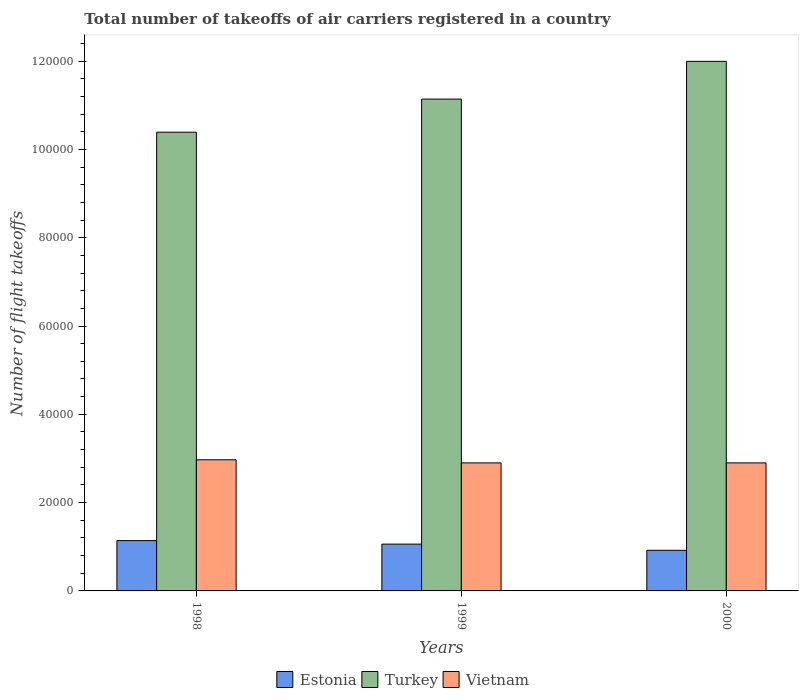How many different coloured bars are there?
Give a very brief answer. 3. Are the number of bars on each tick of the X-axis equal?
Give a very brief answer. Yes. How many bars are there on the 1st tick from the left?
Your answer should be compact. 3. In how many cases, is the number of bars for a given year not equal to the number of legend labels?
Provide a short and direct response. 0. What is the total number of flight takeoffs in Vietnam in 2000?
Your answer should be compact. 2.90e+04. Across all years, what is the maximum total number of flight takeoffs in Vietnam?
Your answer should be compact. 2.97e+04. Across all years, what is the minimum total number of flight takeoffs in Estonia?
Your answer should be compact. 9199. In which year was the total number of flight takeoffs in Turkey maximum?
Your answer should be very brief. 2000. What is the total total number of flight takeoffs in Vietnam in the graph?
Provide a succinct answer. 8.77e+04. What is the difference between the total number of flight takeoffs in Estonia in 1998 and that in 1999?
Offer a very short reply. 800. What is the difference between the total number of flight takeoffs in Vietnam in 2000 and the total number of flight takeoffs in Estonia in 1998?
Offer a terse response. 1.76e+04. What is the average total number of flight takeoffs in Estonia per year?
Make the answer very short. 1.04e+04. In the year 1998, what is the difference between the total number of flight takeoffs in Estonia and total number of flight takeoffs in Vietnam?
Offer a terse response. -1.83e+04. In how many years, is the total number of flight takeoffs in Vietnam greater than 4000?
Offer a very short reply. 3. What is the ratio of the total number of flight takeoffs in Estonia in 1999 to that in 2000?
Give a very brief answer. 1.15. Is the total number of flight takeoffs in Vietnam in 1998 less than that in 1999?
Offer a terse response. No. What is the difference between the highest and the second highest total number of flight takeoffs in Estonia?
Offer a very short reply. 800. What is the difference between the highest and the lowest total number of flight takeoffs in Vietnam?
Ensure brevity in your answer.  701. Is the sum of the total number of flight takeoffs in Vietnam in 1998 and 2000 greater than the maximum total number of flight takeoffs in Turkey across all years?
Keep it short and to the point. No. What does the 2nd bar from the right in 1999 represents?
Your response must be concise. Turkey. How many bars are there?
Make the answer very short. 9. Are all the bars in the graph horizontal?
Provide a short and direct response. No. Does the graph contain grids?
Make the answer very short. No. Where does the legend appear in the graph?
Your answer should be compact. Bottom center. How many legend labels are there?
Your response must be concise. 3. How are the legend labels stacked?
Keep it short and to the point. Horizontal. What is the title of the graph?
Keep it short and to the point. Total number of takeoffs of air carriers registered in a country. What is the label or title of the X-axis?
Keep it short and to the point. Years. What is the label or title of the Y-axis?
Offer a very short reply. Number of flight takeoffs. What is the Number of flight takeoffs of Estonia in 1998?
Your response must be concise. 1.14e+04. What is the Number of flight takeoffs in Turkey in 1998?
Offer a terse response. 1.04e+05. What is the Number of flight takeoffs in Vietnam in 1998?
Provide a succinct answer. 2.97e+04. What is the Number of flight takeoffs of Estonia in 1999?
Provide a succinct answer. 1.06e+04. What is the Number of flight takeoffs of Turkey in 1999?
Make the answer very short. 1.11e+05. What is the Number of flight takeoffs of Vietnam in 1999?
Provide a succinct answer. 2.90e+04. What is the Number of flight takeoffs in Estonia in 2000?
Offer a very short reply. 9199. What is the Number of flight takeoffs in Turkey in 2000?
Ensure brevity in your answer.  1.20e+05. What is the Number of flight takeoffs in Vietnam in 2000?
Ensure brevity in your answer.  2.90e+04. Across all years, what is the maximum Number of flight takeoffs in Estonia?
Your answer should be compact. 1.14e+04. Across all years, what is the maximum Number of flight takeoffs of Turkey?
Make the answer very short. 1.20e+05. Across all years, what is the maximum Number of flight takeoffs in Vietnam?
Your response must be concise. 2.97e+04. Across all years, what is the minimum Number of flight takeoffs in Estonia?
Provide a short and direct response. 9199. Across all years, what is the minimum Number of flight takeoffs of Turkey?
Make the answer very short. 1.04e+05. Across all years, what is the minimum Number of flight takeoffs of Vietnam?
Keep it short and to the point. 2.90e+04. What is the total Number of flight takeoffs of Estonia in the graph?
Ensure brevity in your answer.  3.12e+04. What is the total Number of flight takeoffs of Turkey in the graph?
Give a very brief answer. 3.35e+05. What is the total Number of flight takeoffs in Vietnam in the graph?
Offer a terse response. 8.77e+04. What is the difference between the Number of flight takeoffs in Estonia in 1998 and that in 1999?
Provide a short and direct response. 800. What is the difference between the Number of flight takeoffs of Turkey in 1998 and that in 1999?
Your response must be concise. -7500. What is the difference between the Number of flight takeoffs of Vietnam in 1998 and that in 1999?
Offer a very short reply. 700. What is the difference between the Number of flight takeoffs in Estonia in 1998 and that in 2000?
Provide a succinct answer. 2201. What is the difference between the Number of flight takeoffs in Turkey in 1998 and that in 2000?
Make the answer very short. -1.60e+04. What is the difference between the Number of flight takeoffs of Vietnam in 1998 and that in 2000?
Your answer should be compact. 701. What is the difference between the Number of flight takeoffs in Estonia in 1999 and that in 2000?
Your answer should be very brief. 1401. What is the difference between the Number of flight takeoffs of Turkey in 1999 and that in 2000?
Your answer should be very brief. -8545. What is the difference between the Number of flight takeoffs in Vietnam in 1999 and that in 2000?
Provide a short and direct response. 1. What is the difference between the Number of flight takeoffs in Estonia in 1998 and the Number of flight takeoffs in Vietnam in 1999?
Offer a terse response. -1.76e+04. What is the difference between the Number of flight takeoffs in Turkey in 1998 and the Number of flight takeoffs in Vietnam in 1999?
Give a very brief answer. 7.49e+04. What is the difference between the Number of flight takeoffs of Estonia in 1998 and the Number of flight takeoffs of Turkey in 2000?
Your answer should be compact. -1.09e+05. What is the difference between the Number of flight takeoffs in Estonia in 1998 and the Number of flight takeoffs in Vietnam in 2000?
Keep it short and to the point. -1.76e+04. What is the difference between the Number of flight takeoffs of Turkey in 1998 and the Number of flight takeoffs of Vietnam in 2000?
Provide a succinct answer. 7.49e+04. What is the difference between the Number of flight takeoffs in Estonia in 1999 and the Number of flight takeoffs in Turkey in 2000?
Offer a terse response. -1.09e+05. What is the difference between the Number of flight takeoffs in Estonia in 1999 and the Number of flight takeoffs in Vietnam in 2000?
Make the answer very short. -1.84e+04. What is the difference between the Number of flight takeoffs in Turkey in 1999 and the Number of flight takeoffs in Vietnam in 2000?
Provide a short and direct response. 8.24e+04. What is the average Number of flight takeoffs of Estonia per year?
Provide a succinct answer. 1.04e+04. What is the average Number of flight takeoffs of Turkey per year?
Your answer should be very brief. 1.12e+05. What is the average Number of flight takeoffs of Vietnam per year?
Your answer should be very brief. 2.92e+04. In the year 1998, what is the difference between the Number of flight takeoffs of Estonia and Number of flight takeoffs of Turkey?
Offer a terse response. -9.25e+04. In the year 1998, what is the difference between the Number of flight takeoffs in Estonia and Number of flight takeoffs in Vietnam?
Provide a short and direct response. -1.83e+04. In the year 1998, what is the difference between the Number of flight takeoffs in Turkey and Number of flight takeoffs in Vietnam?
Give a very brief answer. 7.42e+04. In the year 1999, what is the difference between the Number of flight takeoffs in Estonia and Number of flight takeoffs in Turkey?
Provide a short and direct response. -1.01e+05. In the year 1999, what is the difference between the Number of flight takeoffs of Estonia and Number of flight takeoffs of Vietnam?
Make the answer very short. -1.84e+04. In the year 1999, what is the difference between the Number of flight takeoffs of Turkey and Number of flight takeoffs of Vietnam?
Your answer should be very brief. 8.24e+04. In the year 2000, what is the difference between the Number of flight takeoffs in Estonia and Number of flight takeoffs in Turkey?
Offer a very short reply. -1.11e+05. In the year 2000, what is the difference between the Number of flight takeoffs of Estonia and Number of flight takeoffs of Vietnam?
Offer a very short reply. -1.98e+04. In the year 2000, what is the difference between the Number of flight takeoffs in Turkey and Number of flight takeoffs in Vietnam?
Your answer should be compact. 9.09e+04. What is the ratio of the Number of flight takeoffs of Estonia in 1998 to that in 1999?
Provide a short and direct response. 1.08. What is the ratio of the Number of flight takeoffs of Turkey in 1998 to that in 1999?
Offer a terse response. 0.93. What is the ratio of the Number of flight takeoffs of Vietnam in 1998 to that in 1999?
Provide a short and direct response. 1.02. What is the ratio of the Number of flight takeoffs of Estonia in 1998 to that in 2000?
Your response must be concise. 1.24. What is the ratio of the Number of flight takeoffs in Turkey in 1998 to that in 2000?
Your response must be concise. 0.87. What is the ratio of the Number of flight takeoffs of Vietnam in 1998 to that in 2000?
Offer a terse response. 1.02. What is the ratio of the Number of flight takeoffs of Estonia in 1999 to that in 2000?
Keep it short and to the point. 1.15. What is the ratio of the Number of flight takeoffs in Turkey in 1999 to that in 2000?
Offer a very short reply. 0.93. What is the ratio of the Number of flight takeoffs in Vietnam in 1999 to that in 2000?
Give a very brief answer. 1. What is the difference between the highest and the second highest Number of flight takeoffs in Estonia?
Provide a succinct answer. 800. What is the difference between the highest and the second highest Number of flight takeoffs in Turkey?
Provide a succinct answer. 8545. What is the difference between the highest and the second highest Number of flight takeoffs of Vietnam?
Provide a short and direct response. 700. What is the difference between the highest and the lowest Number of flight takeoffs of Estonia?
Your answer should be very brief. 2201. What is the difference between the highest and the lowest Number of flight takeoffs in Turkey?
Your answer should be very brief. 1.60e+04. What is the difference between the highest and the lowest Number of flight takeoffs of Vietnam?
Your answer should be compact. 701. 